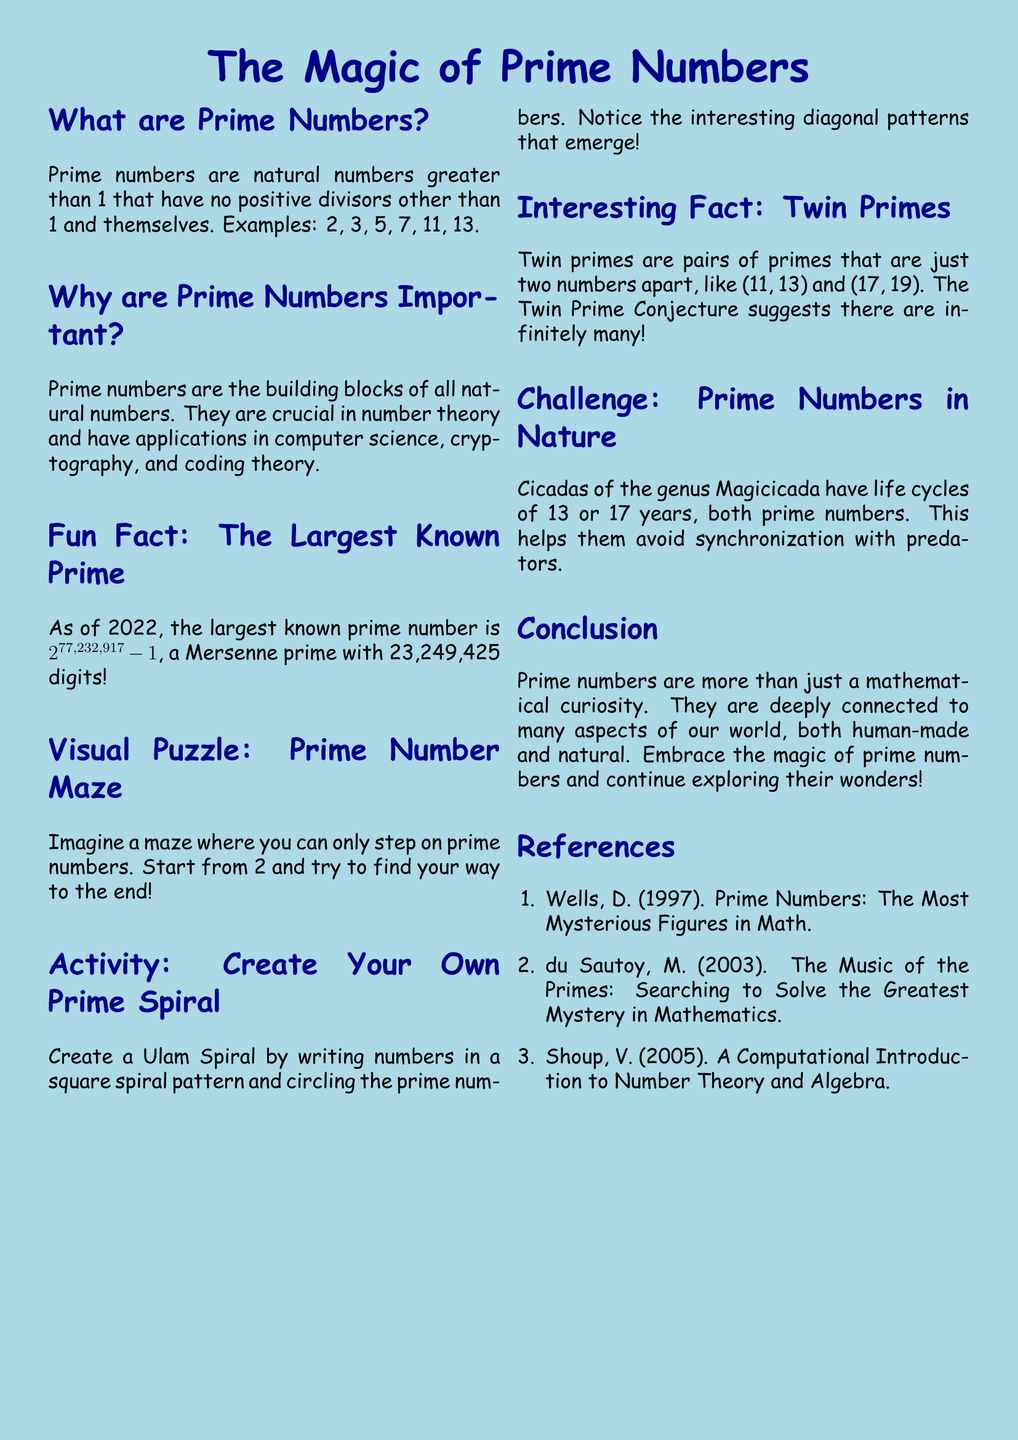What are prime numbers? Prime numbers are defined as natural numbers greater than 1 that have no positive divisors other than 1 and themselves.
Answer: Natural numbers greater than 1 Why are prime numbers important? The document states that prime numbers are the building blocks of all natural numbers and have various applications.
Answer: Building blocks of all natural numbers What is the largest known prime number as of 2022? The document specifically mentions the largest known prime number, which is a Mersenne prime with many digits.
Answer: 2^77,232,917 - 1 What are twin primes? Twin primes are defined in the document as pairs of primes that are just two numbers apart.
Answer: Pairs of primes two numbers apart What is the life cycle duration of cicadas of the genus Magicicada? The document mentions two specific lengths of life cycle for these cicadas, emphasizing their prime nature.
Answer: 13 or 17 years What visual activity is suggested in the document? The document describes an activity where one can create a spiral pattern with numbers while identifying primes.
Answer: Create Your Own Prime Spiral How many digits does the largest known prime number have? The document states that the largest known prime has a specific number of digits.
Answer: 23,249,425 digits What conjecture is mentioned in relation to twin primes? The document refers to a specific conjecture that involves the infinitude of twin primes.
Answer: Twin Prime Conjecture 